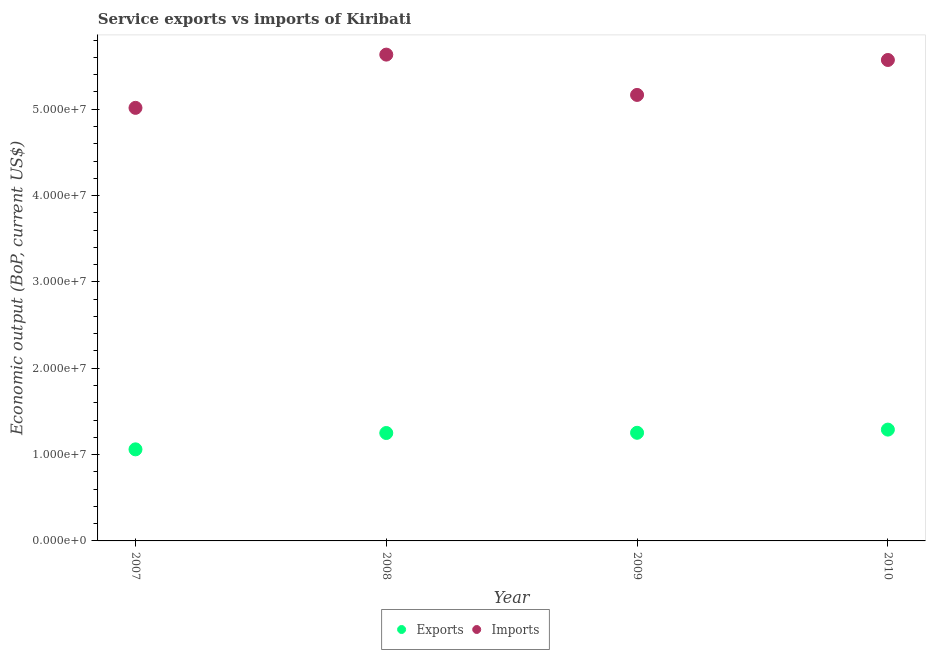Is the number of dotlines equal to the number of legend labels?
Your response must be concise. Yes. What is the amount of service imports in 2009?
Your answer should be compact. 5.17e+07. Across all years, what is the maximum amount of service exports?
Your response must be concise. 1.29e+07. Across all years, what is the minimum amount of service imports?
Your answer should be very brief. 5.02e+07. In which year was the amount of service exports maximum?
Your answer should be very brief. 2010. What is the total amount of service imports in the graph?
Ensure brevity in your answer.  2.14e+08. What is the difference between the amount of service exports in 2007 and that in 2009?
Provide a succinct answer. -1.92e+06. What is the difference between the amount of service exports in 2007 and the amount of service imports in 2010?
Ensure brevity in your answer.  -4.51e+07. What is the average amount of service imports per year?
Your response must be concise. 5.35e+07. In the year 2008, what is the difference between the amount of service imports and amount of service exports?
Offer a terse response. 4.38e+07. What is the ratio of the amount of service imports in 2007 to that in 2010?
Your answer should be very brief. 0.9. What is the difference between the highest and the second highest amount of service imports?
Offer a terse response. 6.22e+05. What is the difference between the highest and the lowest amount of service imports?
Keep it short and to the point. 6.17e+06. In how many years, is the amount of service imports greater than the average amount of service imports taken over all years?
Your answer should be very brief. 2. How many dotlines are there?
Your answer should be compact. 2. Are the values on the major ticks of Y-axis written in scientific E-notation?
Offer a very short reply. Yes. Does the graph contain any zero values?
Your answer should be compact. No. Does the graph contain grids?
Offer a very short reply. No. How many legend labels are there?
Your answer should be compact. 2. What is the title of the graph?
Offer a very short reply. Service exports vs imports of Kiribati. Does "Working only" appear as one of the legend labels in the graph?
Your response must be concise. No. What is the label or title of the Y-axis?
Your answer should be very brief. Economic output (BoP, current US$). What is the Economic output (BoP, current US$) of Exports in 2007?
Your response must be concise. 1.06e+07. What is the Economic output (BoP, current US$) in Imports in 2007?
Give a very brief answer. 5.02e+07. What is the Economic output (BoP, current US$) of Exports in 2008?
Your response must be concise. 1.25e+07. What is the Economic output (BoP, current US$) in Imports in 2008?
Your response must be concise. 5.63e+07. What is the Economic output (BoP, current US$) of Exports in 2009?
Keep it short and to the point. 1.25e+07. What is the Economic output (BoP, current US$) of Imports in 2009?
Keep it short and to the point. 5.17e+07. What is the Economic output (BoP, current US$) of Exports in 2010?
Ensure brevity in your answer.  1.29e+07. What is the Economic output (BoP, current US$) of Imports in 2010?
Your answer should be very brief. 5.57e+07. Across all years, what is the maximum Economic output (BoP, current US$) of Exports?
Keep it short and to the point. 1.29e+07. Across all years, what is the maximum Economic output (BoP, current US$) in Imports?
Your response must be concise. 5.63e+07. Across all years, what is the minimum Economic output (BoP, current US$) in Exports?
Keep it short and to the point. 1.06e+07. Across all years, what is the minimum Economic output (BoP, current US$) of Imports?
Offer a terse response. 5.02e+07. What is the total Economic output (BoP, current US$) of Exports in the graph?
Offer a terse response. 4.85e+07. What is the total Economic output (BoP, current US$) in Imports in the graph?
Provide a short and direct response. 2.14e+08. What is the difference between the Economic output (BoP, current US$) in Exports in 2007 and that in 2008?
Provide a short and direct response. -1.89e+06. What is the difference between the Economic output (BoP, current US$) in Imports in 2007 and that in 2008?
Your answer should be very brief. -6.17e+06. What is the difference between the Economic output (BoP, current US$) of Exports in 2007 and that in 2009?
Your response must be concise. -1.92e+06. What is the difference between the Economic output (BoP, current US$) of Imports in 2007 and that in 2009?
Your response must be concise. -1.50e+06. What is the difference between the Economic output (BoP, current US$) of Exports in 2007 and that in 2010?
Offer a terse response. -2.29e+06. What is the difference between the Economic output (BoP, current US$) of Imports in 2007 and that in 2010?
Offer a terse response. -5.55e+06. What is the difference between the Economic output (BoP, current US$) in Exports in 2008 and that in 2009?
Your response must be concise. -2.52e+04. What is the difference between the Economic output (BoP, current US$) of Imports in 2008 and that in 2009?
Provide a short and direct response. 4.67e+06. What is the difference between the Economic output (BoP, current US$) of Exports in 2008 and that in 2010?
Keep it short and to the point. -3.94e+05. What is the difference between the Economic output (BoP, current US$) in Imports in 2008 and that in 2010?
Your answer should be very brief. 6.22e+05. What is the difference between the Economic output (BoP, current US$) in Exports in 2009 and that in 2010?
Offer a terse response. -3.68e+05. What is the difference between the Economic output (BoP, current US$) of Imports in 2009 and that in 2010?
Your answer should be compact. -4.05e+06. What is the difference between the Economic output (BoP, current US$) in Exports in 2007 and the Economic output (BoP, current US$) in Imports in 2008?
Offer a terse response. -4.57e+07. What is the difference between the Economic output (BoP, current US$) in Exports in 2007 and the Economic output (BoP, current US$) in Imports in 2009?
Your answer should be compact. -4.11e+07. What is the difference between the Economic output (BoP, current US$) in Exports in 2007 and the Economic output (BoP, current US$) in Imports in 2010?
Make the answer very short. -4.51e+07. What is the difference between the Economic output (BoP, current US$) of Exports in 2008 and the Economic output (BoP, current US$) of Imports in 2009?
Ensure brevity in your answer.  -3.92e+07. What is the difference between the Economic output (BoP, current US$) of Exports in 2008 and the Economic output (BoP, current US$) of Imports in 2010?
Keep it short and to the point. -4.32e+07. What is the difference between the Economic output (BoP, current US$) of Exports in 2009 and the Economic output (BoP, current US$) of Imports in 2010?
Give a very brief answer. -4.32e+07. What is the average Economic output (BoP, current US$) in Exports per year?
Keep it short and to the point. 1.21e+07. What is the average Economic output (BoP, current US$) in Imports per year?
Offer a terse response. 5.35e+07. In the year 2007, what is the difference between the Economic output (BoP, current US$) in Exports and Economic output (BoP, current US$) in Imports?
Provide a short and direct response. -3.96e+07. In the year 2008, what is the difference between the Economic output (BoP, current US$) in Exports and Economic output (BoP, current US$) in Imports?
Your answer should be very brief. -4.38e+07. In the year 2009, what is the difference between the Economic output (BoP, current US$) in Exports and Economic output (BoP, current US$) in Imports?
Ensure brevity in your answer.  -3.91e+07. In the year 2010, what is the difference between the Economic output (BoP, current US$) in Exports and Economic output (BoP, current US$) in Imports?
Make the answer very short. -4.28e+07. What is the ratio of the Economic output (BoP, current US$) in Exports in 2007 to that in 2008?
Provide a succinct answer. 0.85. What is the ratio of the Economic output (BoP, current US$) of Imports in 2007 to that in 2008?
Make the answer very short. 0.89. What is the ratio of the Economic output (BoP, current US$) in Exports in 2007 to that in 2009?
Ensure brevity in your answer.  0.85. What is the ratio of the Economic output (BoP, current US$) in Imports in 2007 to that in 2009?
Your answer should be very brief. 0.97. What is the ratio of the Economic output (BoP, current US$) of Exports in 2007 to that in 2010?
Keep it short and to the point. 0.82. What is the ratio of the Economic output (BoP, current US$) in Imports in 2007 to that in 2010?
Offer a very short reply. 0.9. What is the ratio of the Economic output (BoP, current US$) in Imports in 2008 to that in 2009?
Your response must be concise. 1.09. What is the ratio of the Economic output (BoP, current US$) of Exports in 2008 to that in 2010?
Give a very brief answer. 0.97. What is the ratio of the Economic output (BoP, current US$) in Imports in 2008 to that in 2010?
Ensure brevity in your answer.  1.01. What is the ratio of the Economic output (BoP, current US$) of Exports in 2009 to that in 2010?
Your answer should be very brief. 0.97. What is the ratio of the Economic output (BoP, current US$) of Imports in 2009 to that in 2010?
Keep it short and to the point. 0.93. What is the difference between the highest and the second highest Economic output (BoP, current US$) in Exports?
Offer a very short reply. 3.68e+05. What is the difference between the highest and the second highest Economic output (BoP, current US$) of Imports?
Make the answer very short. 6.22e+05. What is the difference between the highest and the lowest Economic output (BoP, current US$) of Exports?
Your answer should be compact. 2.29e+06. What is the difference between the highest and the lowest Economic output (BoP, current US$) in Imports?
Make the answer very short. 6.17e+06. 